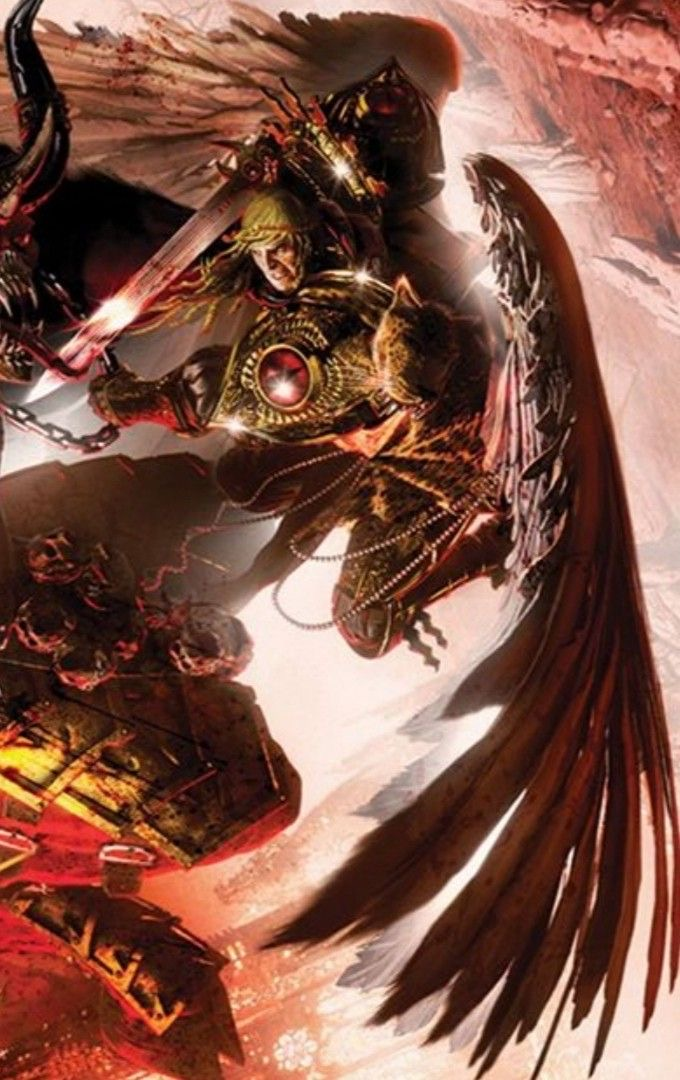describe  The image depicts a fantastical, demonic creature, likely inspired by Aztec or Mayan mythological figures. The being has a fearsome, skeletal face adorned with an elaborate headdress featuring skull-like designs and feathers. Its body appears to be part human and part beast, with clawed hands, wings, and a long tail.

The creature is shown in motion, as if descending from the sky, with its wings and tail spread out dramatically. The color palette is predominantly dark and earthy, with shades of red, brown, and black, giving the artwork an ominous and foreboding atmosphere.

The attention to detail in the creature's design, such as the intricate patterns on its headdress and the textures of its wings and tail, showcase the artist's skill and imagination. The artwork successfully captures a sense of power, danger, and otherworldly mystique associated with ancient Mesoamerican deities and supernatural beings. describe The image depicts a fearsome, supernatural creature descending from a fiery, red sky. The being appears to be a fusion of human, animal, and mythological elements, creating a striking and intimidating presence.

The creature's face resembles a human skull, with hollow eye sockets and a gaping mouth filled with sharp teeth. Atop its head sits an elaborate headdress adorned with intricate patterns, feathers, and what appears to be a smaller skull. This headdress adds to the being's regal and ominous appearance.

The creature's body is a blend of humanoid and bestial features. It has muscular, humanoid arms that end in clawed hands, while its legs are replaced by a long, serpentine tail. Sprouting from its back are two large, feathered wings, giving the impression that this being can take flight.

The color scheme is dominated by shades of red, orange, and black, creating a sense of heat, danger, and darkness. The background suggests a sky ablaze, possibly alluding to an apocalyptic or hellish setting.

The artwork's style and subject matter seem to draw inspiration from Aztec, Mayan, or other Mesoamerican mythologies, as the creature bears resemblance to deities or supernatural entities often depicted in their art and folklore. The attention to detail and the dynamic pose of the creature make for a visually striking and memorable image that captures the imagination. 